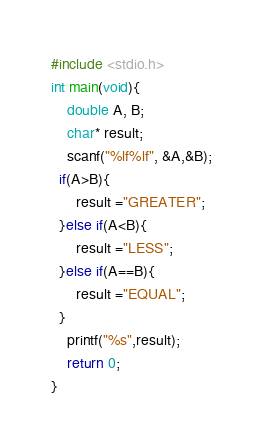<code> <loc_0><loc_0><loc_500><loc_500><_C_>#include <stdio.h>
int main(void){
    double A, B;
    char* result;
    scanf("%lf%lf", &A,&B);
  if(A>B){
      result ="GREATER";
  }else if(A<B){
      result ="LESS";
  }else if(A==B){
      result ="EQUAL";
  }
    printf("%s",result);
    return 0;
}</code> 